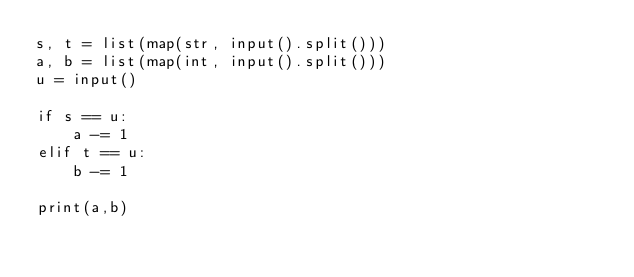Convert code to text. <code><loc_0><loc_0><loc_500><loc_500><_Python_>s, t = list(map(str, input().split()))
a, b = list(map(int, input().split()))
u = input()

if s == u:
    a -= 1
elif t == u:
    b -= 1

print(a,b)</code> 